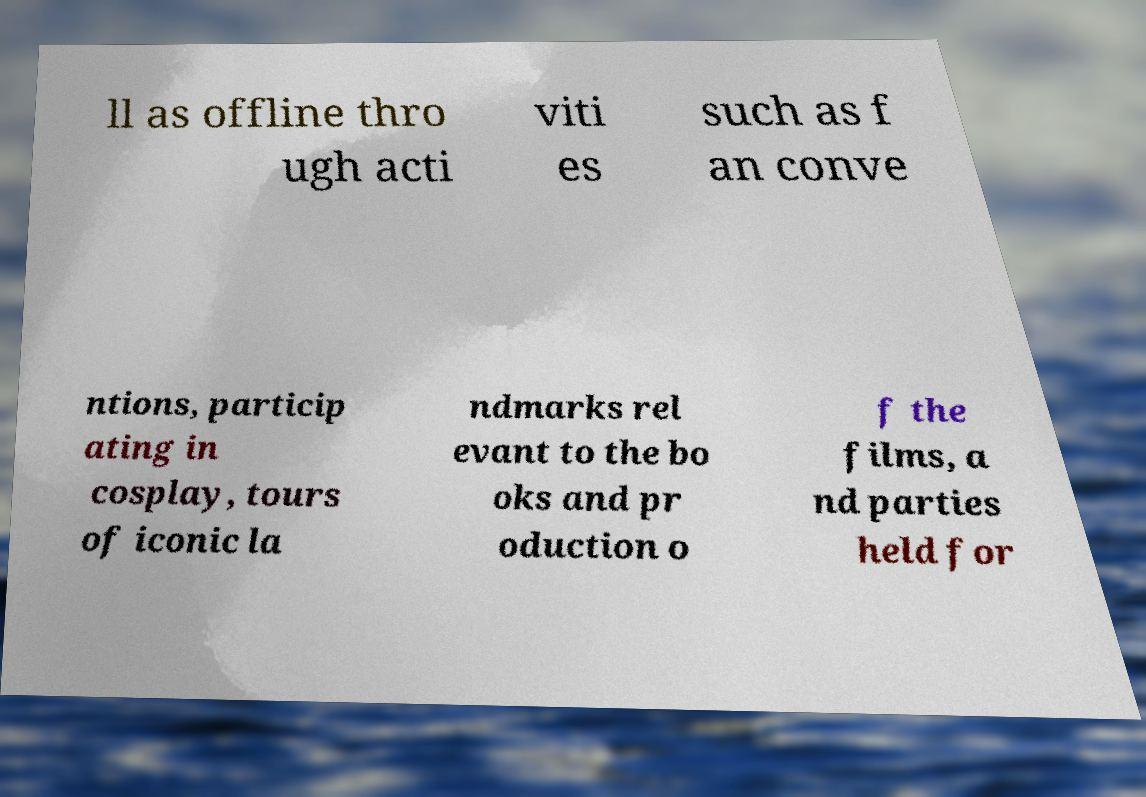Please identify and transcribe the text found in this image. ll as offline thro ugh acti viti es such as f an conve ntions, particip ating in cosplay, tours of iconic la ndmarks rel evant to the bo oks and pr oduction o f the films, a nd parties held for 